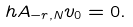Convert formula to latex. <formula><loc_0><loc_0><loc_500><loc_500>\ h A _ { - r , N } v _ { 0 } = 0 .</formula> 